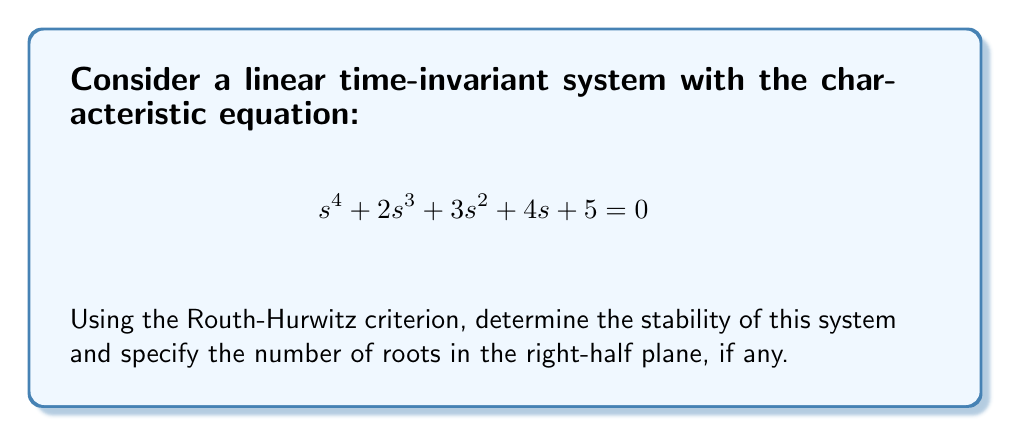Help me with this question. To analyze the stability using the Routh-Hurwitz criterion, we follow these steps:

1) Construct the Routh array:

   $$\begin{array}{c|cccc}
   s^4 & 1 & 3 & 5 \\
   s^3 & 2 & 4 & 0 \\
   s^2 & b_1 & b_2 & \\
   s^1 & c_1 & & \\
   s^0 & d_1 & &
   \end{array}$$

2) Calculate $b_1$:
   $$b_1 = \frac{(2)(3) - (1)(4)}{2} = 1$$

3) Calculate $b_2$:
   $$b_2 = \frac{(2)(5) - (1)(0)}{2} = 5$$

4) Calculate $c_1$:
   $$c_1 = \frac{(1)(4) - (2)(5)}{1} = -6$$

5) Calculate $d_1$:
   $$d_1 = \frac{(-6)(5) - (1)(0)}{-6} = 5$$

6) The complete Routh array:

   $$\begin{array}{c|cccc}
   s^4 & 1 & 3 & 5 \\
   s^3 & 2 & 4 & 0 \\
   s^2 & 1 & 5 & \\
   s^1 & -6 & & \\
   s^0 & 5 & &
   \end{array}$$

7) Analyze the signs in the first column:
   There is one sign change (from -6 to 5) in the first column.

8) According to the Routh-Hurwitz criterion:
   - The number of sign changes in the first column equals the number of roots in the right-half plane.
   - For stability, all elements in the first column should be positive.

Therefore, the system is unstable with one root in the right-half plane.
Answer: Unstable; 1 root in right-half plane 